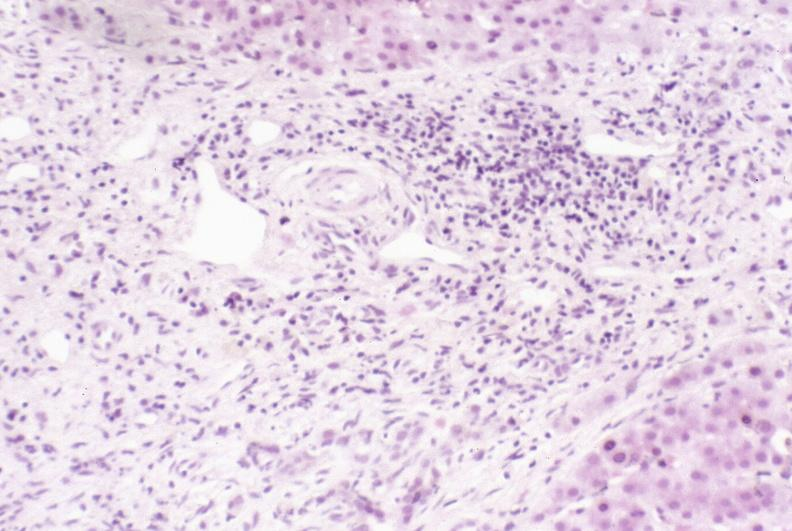does case of peritonitis slide show primary sclerosing cholangitis?
Answer the question using a single word or phrase. No 